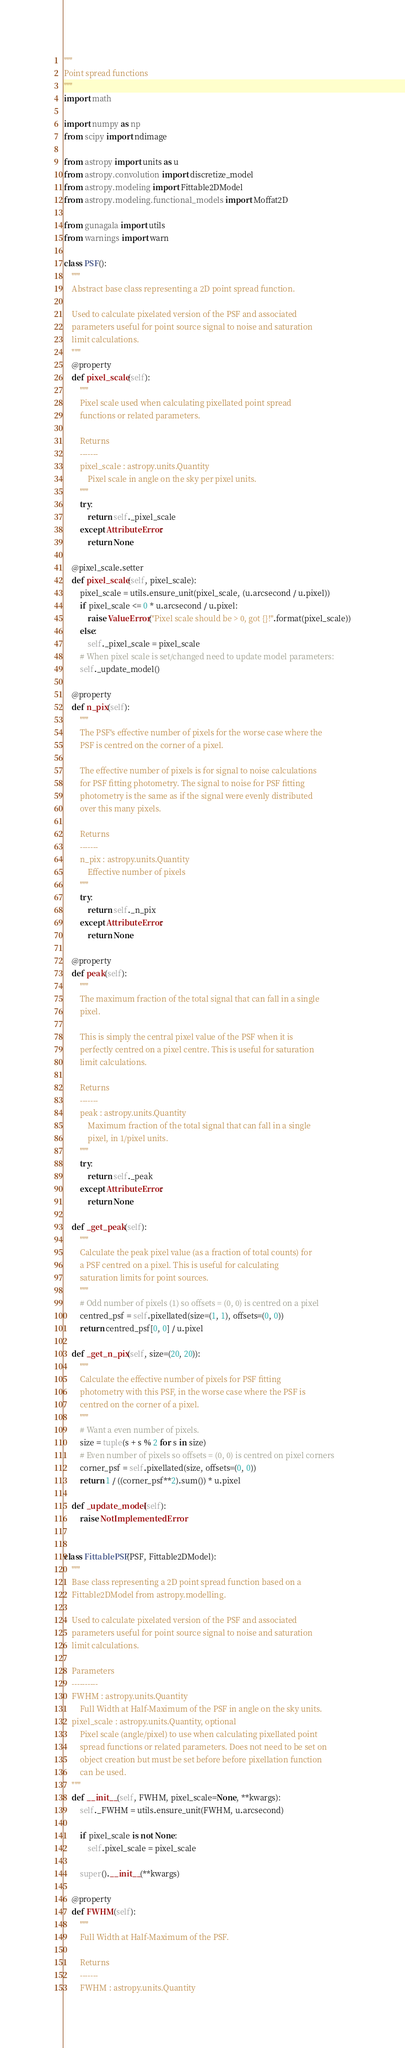Convert code to text. <code><loc_0><loc_0><loc_500><loc_500><_Python_>"""
Point spread functions
"""
import math

import numpy as np
from scipy import ndimage

from astropy import units as u
from astropy.convolution import discretize_model
from astropy.modeling import Fittable2DModel
from astropy.modeling.functional_models import Moffat2D

from gunagala import utils
from warnings import warn

class PSF():
    """
    Abstract base class representing a 2D point spread function.

    Used to calculate pixelated version of the PSF and associated
    parameters useful for point source signal to noise and saturation
    limit calculations.
    """
    @property
    def pixel_scale(self):
        """
        Pixel scale used when calculating pixellated point spread
        functions or related parameters.

        Returns
        -------
        pixel_scale : astropy.units.Quantity
            Pixel scale in angle on the sky per pixel units.
        """
        try:
            return self._pixel_scale
        except AttributeError:
            return None

    @pixel_scale.setter
    def pixel_scale(self, pixel_scale):
        pixel_scale = utils.ensure_unit(pixel_scale, (u.arcsecond / u.pixel))
        if pixel_scale <= 0 * u.arcsecond / u.pixel:
            raise ValueError("Pixel scale should be > 0, got {}!".format(pixel_scale))
        else:
            self._pixel_scale = pixel_scale
        # When pixel scale is set/changed need to update model parameters:
        self._update_model()

    @property
    def n_pix(self):
        """
        The PSF's effective number of pixels for the worse case where the
        PSF is centred on the corner of a pixel.

        The effective number of pixels is for signal to noise calculations
        for PSF fitting photometry. The signal to noise for PSF fitting
        photometry is the same as if the signal were evenly distributed
        over this many pixels.

        Returns
        -------
        n_pix : astropy.units.Quantity
            Effective number of pixels
        """
        try:
            return self._n_pix
        except AttributeError:
            return None

    @property
    def peak(self):
        """
        The maximum fraction of the total signal that can fall in a single
        pixel.

        This is simply the central pixel value of the PSF when it is
        perfectly centred on a pixel centre. This is useful for saturation
        limit calculations.

        Returns
        -------
        peak : astropy.units.Quantity
            Maximum fraction of the total signal that can fall in a single
            pixel, in 1/pixel units.
        """
        try:
            return self._peak
        except AttributeError:
            return None

    def _get_peak(self):
        """
        Calculate the peak pixel value (as a fraction of total counts) for
        a PSF centred on a pixel. This is useful for calculating
        saturation limits for point sources.
        """
        # Odd number of pixels (1) so offsets = (0, 0) is centred on a pixel
        centred_psf = self.pixellated(size=(1, 1), offsets=(0, 0))
        return centred_psf[0, 0] / u.pixel

    def _get_n_pix(self, size=(20, 20)):
        """
        Calculate the effective number of pixels for PSF fitting
        photometry with this PSF, in the worse case where the PSF is
        centred on the corner of a pixel.
        """
        # Want a even number of pixels.
        size = tuple(s + s % 2 for s in size)
        # Even number of pixels so offsets = (0, 0) is centred on pixel corners
        corner_psf = self.pixellated(size, offsets=(0, 0))
        return 1 / ((corner_psf**2).sum()) * u.pixel

    def _update_model(self):
        raise NotImplementedError


class FittablePSF(PSF, Fittable2DModel):
    """
    Base class representing a 2D point spread function based on a
    Fittable2DModel from astropy.modelling.

    Used to calculate pixelated version of the PSF and associated
    parameters useful for point source signal to noise and saturation
    limit calculations.

    Parameters
    ----------
    FWHM : astropy.units.Quantity
        Full Width at Half-Maximum of the PSF in angle on the sky units.
    pixel_scale : astropy.units.Quantity, optional
        Pixel scale (angle/pixel) to use when calculating pixellated point
        spread functions or related parameters. Does not need to be set on
        object creation but must be set before before pixellation function
        can be used.
    """
    def __init__(self, FWHM, pixel_scale=None, **kwargs):
        self._FWHM = utils.ensure_unit(FWHM, u.arcsecond)

        if pixel_scale is not None:
            self.pixel_scale = pixel_scale

        super().__init__(**kwargs)

    @property
    def FWHM(self):
        """
        Full Width at Half-Maximum of the PSF.

        Returns
        -------
        FWHM : astropy.units.Quantity</code> 